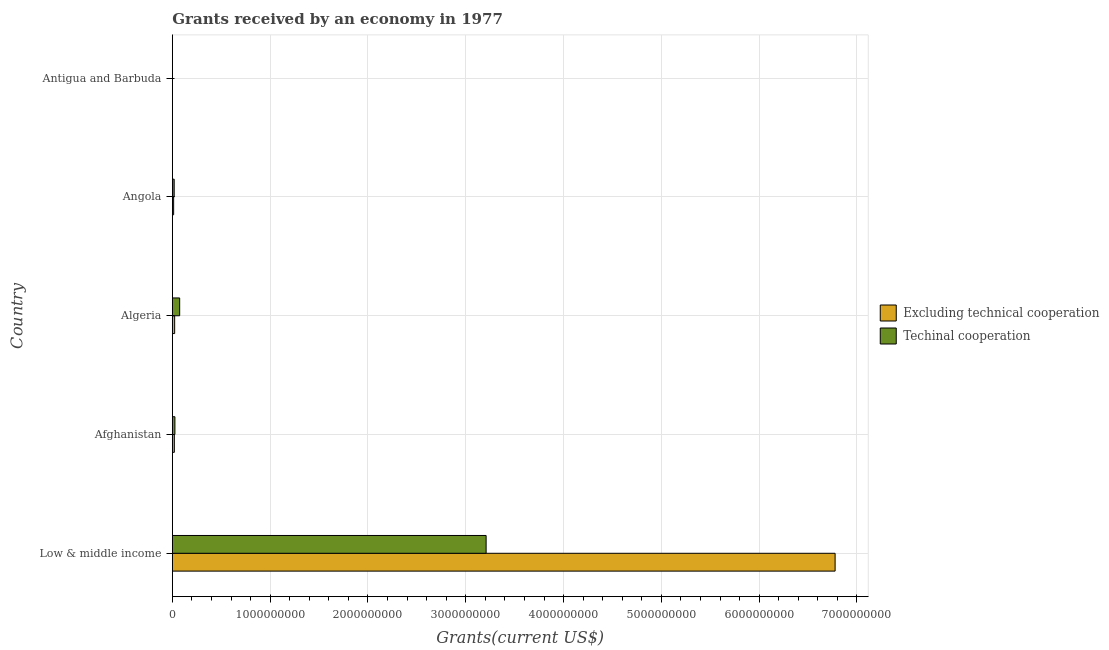How many bars are there on the 1st tick from the bottom?
Your response must be concise. 2. What is the label of the 4th group of bars from the top?
Give a very brief answer. Afghanistan. What is the amount of grants received(excluding technical cooperation) in Afghanistan?
Offer a terse response. 2.02e+07. Across all countries, what is the maximum amount of grants received(including technical cooperation)?
Your answer should be very brief. 3.21e+09. Across all countries, what is the minimum amount of grants received(excluding technical cooperation)?
Make the answer very short. 1.26e+06. In which country was the amount of grants received(excluding technical cooperation) minimum?
Offer a terse response. Antigua and Barbuda. What is the total amount of grants received(excluding technical cooperation) in the graph?
Give a very brief answer. 6.83e+09. What is the difference between the amount of grants received(excluding technical cooperation) in Afghanistan and that in Antigua and Barbuda?
Your response must be concise. 1.89e+07. What is the difference between the amount of grants received(excluding technical cooperation) in Low & middle income and the amount of grants received(including technical cooperation) in Afghanistan?
Keep it short and to the point. 6.75e+09. What is the average amount of grants received(including technical cooperation) per country?
Provide a short and direct response. 6.66e+08. What is the difference between the amount of grants received(excluding technical cooperation) and amount of grants received(including technical cooperation) in Afghanistan?
Provide a short and direct response. -5.84e+06. What is the ratio of the amount of grants received(excluding technical cooperation) in Algeria to that in Antigua and Barbuda?
Make the answer very short. 18.53. Is the amount of grants received(including technical cooperation) in Angola less than that in Low & middle income?
Keep it short and to the point. Yes. Is the difference between the amount of grants received(including technical cooperation) in Antigua and Barbuda and Low & middle income greater than the difference between the amount of grants received(excluding technical cooperation) in Antigua and Barbuda and Low & middle income?
Keep it short and to the point. Yes. What is the difference between the highest and the second highest amount of grants received(excluding technical cooperation)?
Provide a short and direct response. 6.75e+09. What is the difference between the highest and the lowest amount of grants received(excluding technical cooperation)?
Your answer should be very brief. 6.77e+09. What does the 2nd bar from the top in Antigua and Barbuda represents?
Give a very brief answer. Excluding technical cooperation. What does the 2nd bar from the bottom in Antigua and Barbuda represents?
Provide a succinct answer. Techinal cooperation. How many bars are there?
Offer a very short reply. 10. How many countries are there in the graph?
Provide a short and direct response. 5. What is the difference between two consecutive major ticks on the X-axis?
Provide a succinct answer. 1.00e+09. Does the graph contain grids?
Ensure brevity in your answer.  Yes. Where does the legend appear in the graph?
Provide a succinct answer. Center right. What is the title of the graph?
Your answer should be compact. Grants received by an economy in 1977. Does "Resident workers" appear as one of the legend labels in the graph?
Your answer should be very brief. No. What is the label or title of the X-axis?
Provide a succinct answer. Grants(current US$). What is the label or title of the Y-axis?
Keep it short and to the point. Country. What is the Grants(current US$) of Excluding technical cooperation in Low & middle income?
Offer a terse response. 6.78e+09. What is the Grants(current US$) in Techinal cooperation in Low & middle income?
Offer a very short reply. 3.21e+09. What is the Grants(current US$) of Excluding technical cooperation in Afghanistan?
Your response must be concise. 2.02e+07. What is the Grants(current US$) of Techinal cooperation in Afghanistan?
Make the answer very short. 2.60e+07. What is the Grants(current US$) in Excluding technical cooperation in Algeria?
Offer a terse response. 2.34e+07. What is the Grants(current US$) in Techinal cooperation in Algeria?
Provide a short and direct response. 7.47e+07. What is the Grants(current US$) in Excluding technical cooperation in Angola?
Keep it short and to the point. 1.30e+07. What is the Grants(current US$) in Techinal cooperation in Angola?
Ensure brevity in your answer.  1.86e+07. What is the Grants(current US$) of Excluding technical cooperation in Antigua and Barbuda?
Your answer should be very brief. 1.26e+06. What is the Grants(current US$) of Techinal cooperation in Antigua and Barbuda?
Give a very brief answer. 5.60e+05. Across all countries, what is the maximum Grants(current US$) in Excluding technical cooperation?
Give a very brief answer. 6.78e+09. Across all countries, what is the maximum Grants(current US$) of Techinal cooperation?
Offer a terse response. 3.21e+09. Across all countries, what is the minimum Grants(current US$) in Excluding technical cooperation?
Your answer should be very brief. 1.26e+06. Across all countries, what is the minimum Grants(current US$) of Techinal cooperation?
Offer a terse response. 5.60e+05. What is the total Grants(current US$) in Excluding technical cooperation in the graph?
Offer a terse response. 6.83e+09. What is the total Grants(current US$) of Techinal cooperation in the graph?
Offer a very short reply. 3.33e+09. What is the difference between the Grants(current US$) in Excluding technical cooperation in Low & middle income and that in Afghanistan?
Offer a terse response. 6.76e+09. What is the difference between the Grants(current US$) of Techinal cooperation in Low & middle income and that in Afghanistan?
Keep it short and to the point. 3.18e+09. What is the difference between the Grants(current US$) in Excluding technical cooperation in Low & middle income and that in Algeria?
Provide a succinct answer. 6.75e+09. What is the difference between the Grants(current US$) in Techinal cooperation in Low & middle income and that in Algeria?
Give a very brief answer. 3.13e+09. What is the difference between the Grants(current US$) in Excluding technical cooperation in Low & middle income and that in Angola?
Offer a terse response. 6.76e+09. What is the difference between the Grants(current US$) in Techinal cooperation in Low & middle income and that in Angola?
Your answer should be very brief. 3.19e+09. What is the difference between the Grants(current US$) of Excluding technical cooperation in Low & middle income and that in Antigua and Barbuda?
Ensure brevity in your answer.  6.77e+09. What is the difference between the Grants(current US$) in Techinal cooperation in Low & middle income and that in Antigua and Barbuda?
Give a very brief answer. 3.21e+09. What is the difference between the Grants(current US$) of Excluding technical cooperation in Afghanistan and that in Algeria?
Your answer should be compact. -3.20e+06. What is the difference between the Grants(current US$) of Techinal cooperation in Afghanistan and that in Algeria?
Offer a very short reply. -4.87e+07. What is the difference between the Grants(current US$) of Excluding technical cooperation in Afghanistan and that in Angola?
Keep it short and to the point. 7.16e+06. What is the difference between the Grants(current US$) in Techinal cooperation in Afghanistan and that in Angola?
Your answer should be very brief. 7.44e+06. What is the difference between the Grants(current US$) in Excluding technical cooperation in Afghanistan and that in Antigua and Barbuda?
Provide a short and direct response. 1.89e+07. What is the difference between the Grants(current US$) in Techinal cooperation in Afghanistan and that in Antigua and Barbuda?
Offer a terse response. 2.54e+07. What is the difference between the Grants(current US$) of Excluding technical cooperation in Algeria and that in Angola?
Provide a succinct answer. 1.04e+07. What is the difference between the Grants(current US$) in Techinal cooperation in Algeria and that in Angola?
Keep it short and to the point. 5.61e+07. What is the difference between the Grants(current US$) in Excluding technical cooperation in Algeria and that in Antigua and Barbuda?
Give a very brief answer. 2.21e+07. What is the difference between the Grants(current US$) in Techinal cooperation in Algeria and that in Antigua and Barbuda?
Give a very brief answer. 7.41e+07. What is the difference between the Grants(current US$) of Excluding technical cooperation in Angola and that in Antigua and Barbuda?
Provide a succinct answer. 1.17e+07. What is the difference between the Grants(current US$) in Techinal cooperation in Angola and that in Antigua and Barbuda?
Provide a short and direct response. 1.80e+07. What is the difference between the Grants(current US$) of Excluding technical cooperation in Low & middle income and the Grants(current US$) of Techinal cooperation in Afghanistan?
Your answer should be very brief. 6.75e+09. What is the difference between the Grants(current US$) of Excluding technical cooperation in Low & middle income and the Grants(current US$) of Techinal cooperation in Algeria?
Offer a very short reply. 6.70e+09. What is the difference between the Grants(current US$) of Excluding technical cooperation in Low & middle income and the Grants(current US$) of Techinal cooperation in Angola?
Make the answer very short. 6.76e+09. What is the difference between the Grants(current US$) in Excluding technical cooperation in Low & middle income and the Grants(current US$) in Techinal cooperation in Antigua and Barbuda?
Ensure brevity in your answer.  6.78e+09. What is the difference between the Grants(current US$) of Excluding technical cooperation in Afghanistan and the Grants(current US$) of Techinal cooperation in Algeria?
Provide a short and direct response. -5.45e+07. What is the difference between the Grants(current US$) in Excluding technical cooperation in Afghanistan and the Grants(current US$) in Techinal cooperation in Angola?
Offer a terse response. 1.60e+06. What is the difference between the Grants(current US$) in Excluding technical cooperation in Afghanistan and the Grants(current US$) in Techinal cooperation in Antigua and Barbuda?
Provide a succinct answer. 1.96e+07. What is the difference between the Grants(current US$) in Excluding technical cooperation in Algeria and the Grants(current US$) in Techinal cooperation in Angola?
Provide a short and direct response. 4.80e+06. What is the difference between the Grants(current US$) of Excluding technical cooperation in Algeria and the Grants(current US$) of Techinal cooperation in Antigua and Barbuda?
Offer a terse response. 2.28e+07. What is the difference between the Grants(current US$) of Excluding technical cooperation in Angola and the Grants(current US$) of Techinal cooperation in Antigua and Barbuda?
Provide a short and direct response. 1.24e+07. What is the average Grants(current US$) of Excluding technical cooperation per country?
Offer a very short reply. 1.37e+09. What is the average Grants(current US$) in Techinal cooperation per country?
Your answer should be very brief. 6.66e+08. What is the difference between the Grants(current US$) of Excluding technical cooperation and Grants(current US$) of Techinal cooperation in Low & middle income?
Make the answer very short. 3.57e+09. What is the difference between the Grants(current US$) in Excluding technical cooperation and Grants(current US$) in Techinal cooperation in Afghanistan?
Offer a terse response. -5.84e+06. What is the difference between the Grants(current US$) in Excluding technical cooperation and Grants(current US$) in Techinal cooperation in Algeria?
Ensure brevity in your answer.  -5.13e+07. What is the difference between the Grants(current US$) of Excluding technical cooperation and Grants(current US$) of Techinal cooperation in Angola?
Give a very brief answer. -5.56e+06. What is the difference between the Grants(current US$) in Excluding technical cooperation and Grants(current US$) in Techinal cooperation in Antigua and Barbuda?
Give a very brief answer. 7.00e+05. What is the ratio of the Grants(current US$) of Excluding technical cooperation in Low & middle income to that in Afghanistan?
Offer a very short reply. 336.29. What is the ratio of the Grants(current US$) of Techinal cooperation in Low & middle income to that in Afghanistan?
Offer a very short reply. 123.43. What is the ratio of the Grants(current US$) in Excluding technical cooperation in Low & middle income to that in Algeria?
Offer a very short reply. 290.2. What is the ratio of the Grants(current US$) in Techinal cooperation in Low & middle income to that in Algeria?
Offer a terse response. 42.95. What is the ratio of the Grants(current US$) of Excluding technical cooperation in Low & middle income to that in Angola?
Provide a short and direct response. 521.65. What is the ratio of the Grants(current US$) of Techinal cooperation in Low & middle income to that in Angola?
Your answer should be very brief. 172.94. What is the ratio of the Grants(current US$) of Excluding technical cooperation in Low & middle income to that in Antigua and Barbuda?
Provide a succinct answer. 5377.97. What is the ratio of the Grants(current US$) of Techinal cooperation in Low & middle income to that in Antigua and Barbuda?
Make the answer very short. 5728.54. What is the ratio of the Grants(current US$) of Excluding technical cooperation in Afghanistan to that in Algeria?
Offer a very short reply. 0.86. What is the ratio of the Grants(current US$) of Techinal cooperation in Afghanistan to that in Algeria?
Give a very brief answer. 0.35. What is the ratio of the Grants(current US$) of Excluding technical cooperation in Afghanistan to that in Angola?
Make the answer very short. 1.55. What is the ratio of the Grants(current US$) in Techinal cooperation in Afghanistan to that in Angola?
Give a very brief answer. 1.4. What is the ratio of the Grants(current US$) in Excluding technical cooperation in Afghanistan to that in Antigua and Barbuda?
Make the answer very short. 15.99. What is the ratio of the Grants(current US$) of Techinal cooperation in Afghanistan to that in Antigua and Barbuda?
Your response must be concise. 46.41. What is the ratio of the Grants(current US$) of Excluding technical cooperation in Algeria to that in Angola?
Your answer should be compact. 1.8. What is the ratio of the Grants(current US$) of Techinal cooperation in Algeria to that in Angola?
Offer a very short reply. 4.03. What is the ratio of the Grants(current US$) of Excluding technical cooperation in Algeria to that in Antigua and Barbuda?
Give a very brief answer. 18.53. What is the ratio of the Grants(current US$) in Techinal cooperation in Algeria to that in Antigua and Barbuda?
Your answer should be very brief. 133.38. What is the ratio of the Grants(current US$) in Excluding technical cooperation in Angola to that in Antigua and Barbuda?
Offer a very short reply. 10.31. What is the ratio of the Grants(current US$) in Techinal cooperation in Angola to that in Antigua and Barbuda?
Your answer should be compact. 33.12. What is the difference between the highest and the second highest Grants(current US$) of Excluding technical cooperation?
Your response must be concise. 6.75e+09. What is the difference between the highest and the second highest Grants(current US$) in Techinal cooperation?
Offer a very short reply. 3.13e+09. What is the difference between the highest and the lowest Grants(current US$) in Excluding technical cooperation?
Provide a short and direct response. 6.77e+09. What is the difference between the highest and the lowest Grants(current US$) of Techinal cooperation?
Give a very brief answer. 3.21e+09. 